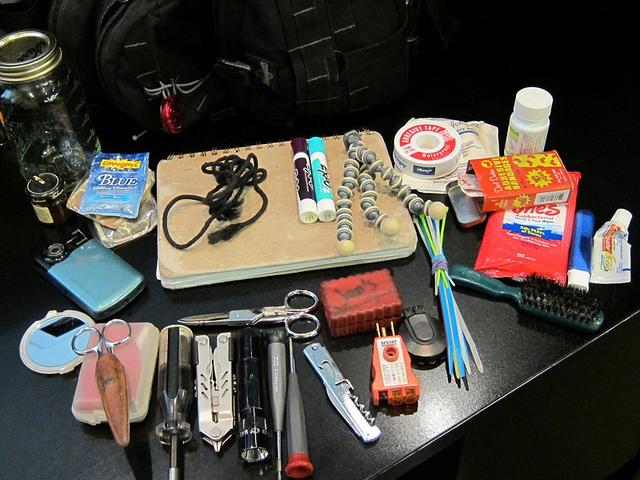What color are the bristles?
Give a very brief answer. Black. Are any of the scissors closed?
Short answer required. Yes. Is there a camera stand in this picture?
Keep it brief. No. How many toothbrushes?
Concise answer only. 0. How many markers are there?
Write a very short answer. 2. All this stuff are related to what?
Write a very short answer. Medical. 